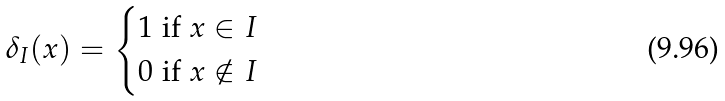Convert formula to latex. <formula><loc_0><loc_0><loc_500><loc_500>\delta _ { I } ( x ) = \begin{cases} 1 \text { if } x \in I \\ 0 \text { if } x \notin I \end{cases}</formula> 